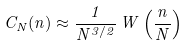<formula> <loc_0><loc_0><loc_500><loc_500>C _ { N } ( n ) \approx \frac { 1 } { N ^ { 3 / 2 } } \, W \left ( \frac { n } { N } \right )</formula> 